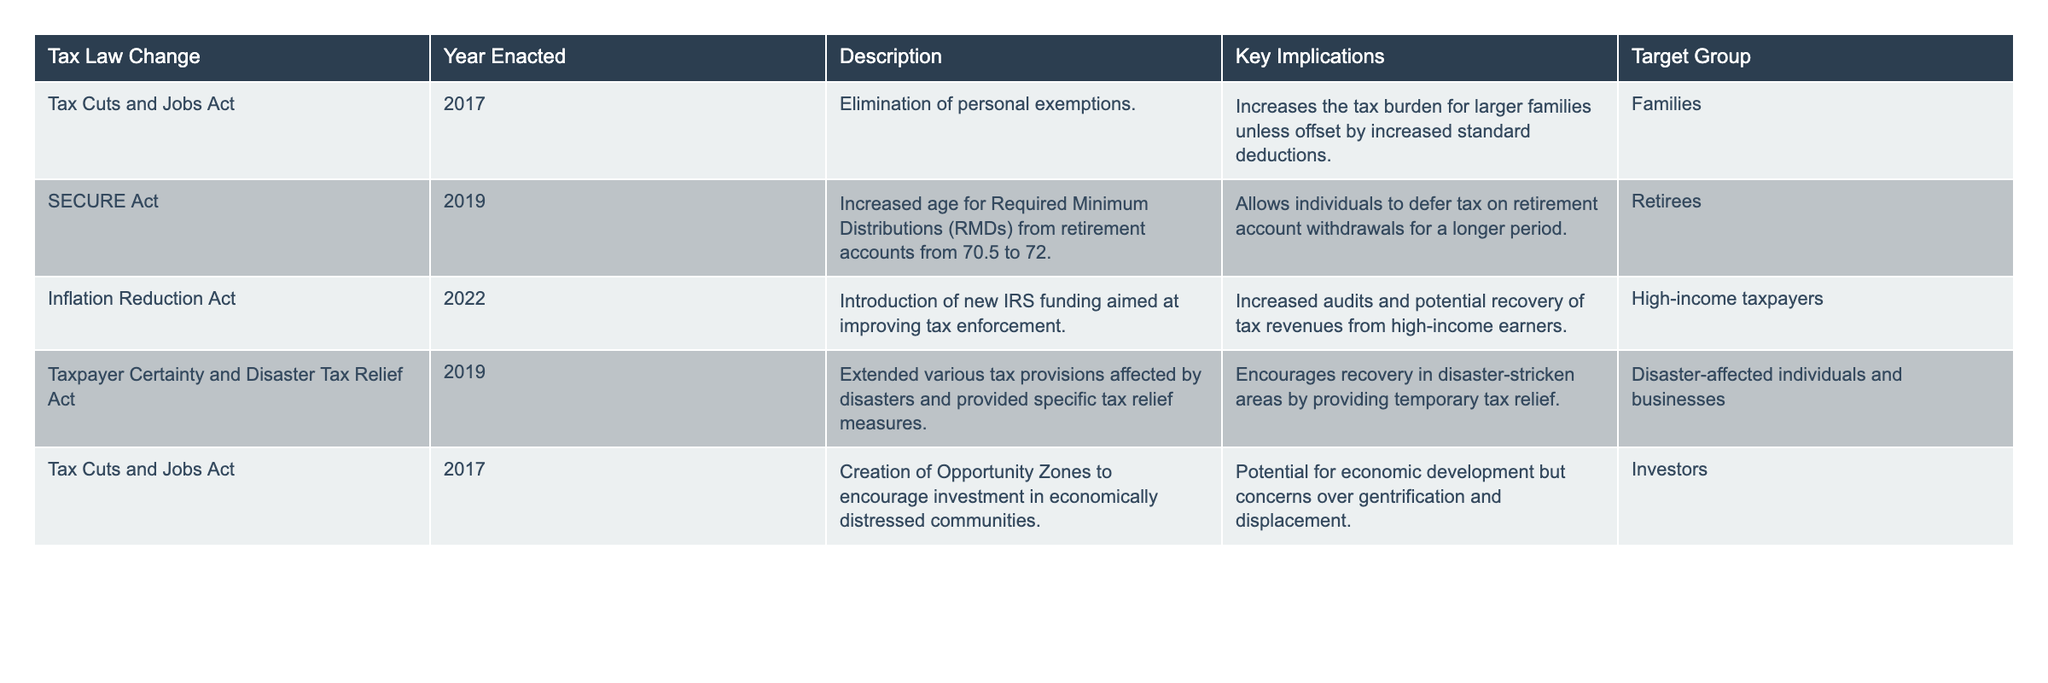What tax law changed related to personal exemptions? The table indicates that the "Tax Cuts and Jobs Act" enacted in 2017 eliminated personal exemptions.
Answer: Tax Cuts and Jobs Act Which year did the SECURE Act take effect? The table shows that the SECURE Act was enacted in 2019.
Answer: 2019 What are the key implications of the Inflation Reduction Act? The key implications are increased audits and potential recovery of tax revenues from high-income earners due to new IRS funding.
Answer: Increased audits How many tax law changes mention a target group of families? From the table, there is one entry under families, which is related to the Tax Cuts and Jobs Act.
Answer: 1 Did the Tax Cuts and Jobs Act create Opportunity Zones? Yes, the table confirms that the Tax Cuts and Jobs Act included the creation of Opportunity Zones.
Answer: Yes What is the main goal of the legislation aimed at disaster-affected individuals? The main goal, according to the Taxpayer Certainty and Disaster Tax Relief Act, is to provide temporary tax relief to encourage recovery in disaster-stricken areas.
Answer: Temporary tax relief How many tax law changes focus on retirees? The SECURE Act is the only entry that focuses on retirees by addressing Required Minimum Distributions.
Answer: 1 What are the implications of the changes made by the SECURE Act? The table states that the SECURE Act allows individuals to defer tax on retirement account withdrawals for a longer period, benefiting retirees.
Answer: Longer deferral of tax Which tax law changes specifically target high-income taxpayers? The Inflation Reduction Act specifically targets high-income taxpayers by introducing new IRS funding for better tax enforcement.
Answer: Inflation Reduction Act What is the relationship between Opportunity Zones and economic development? The table notes that Opportunity Zones aim to encourage investment in economically distressed communities, suggesting a relationship to stimulate economic development.
Answer: Encouragement of investment 